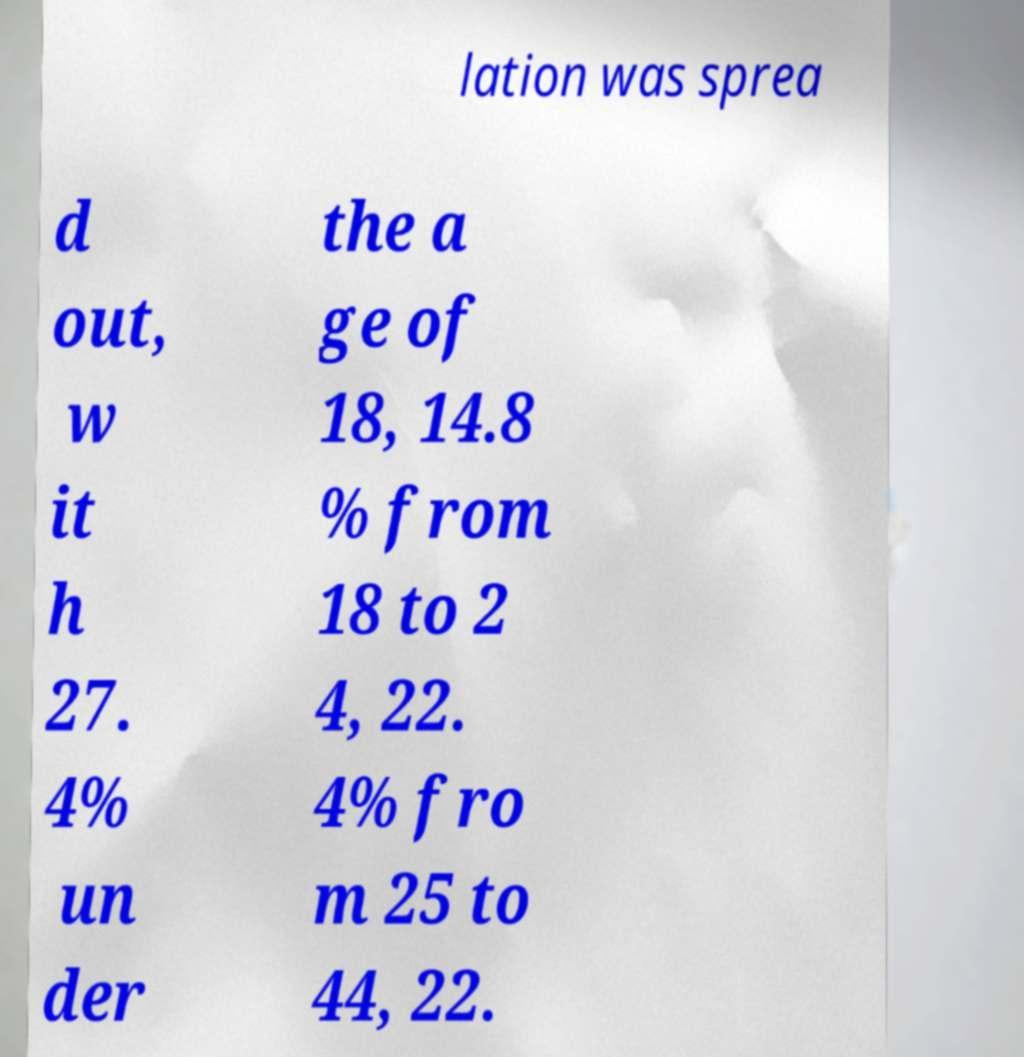There's text embedded in this image that I need extracted. Can you transcribe it verbatim? lation was sprea d out, w it h 27. 4% un der the a ge of 18, 14.8 % from 18 to 2 4, 22. 4% fro m 25 to 44, 22. 